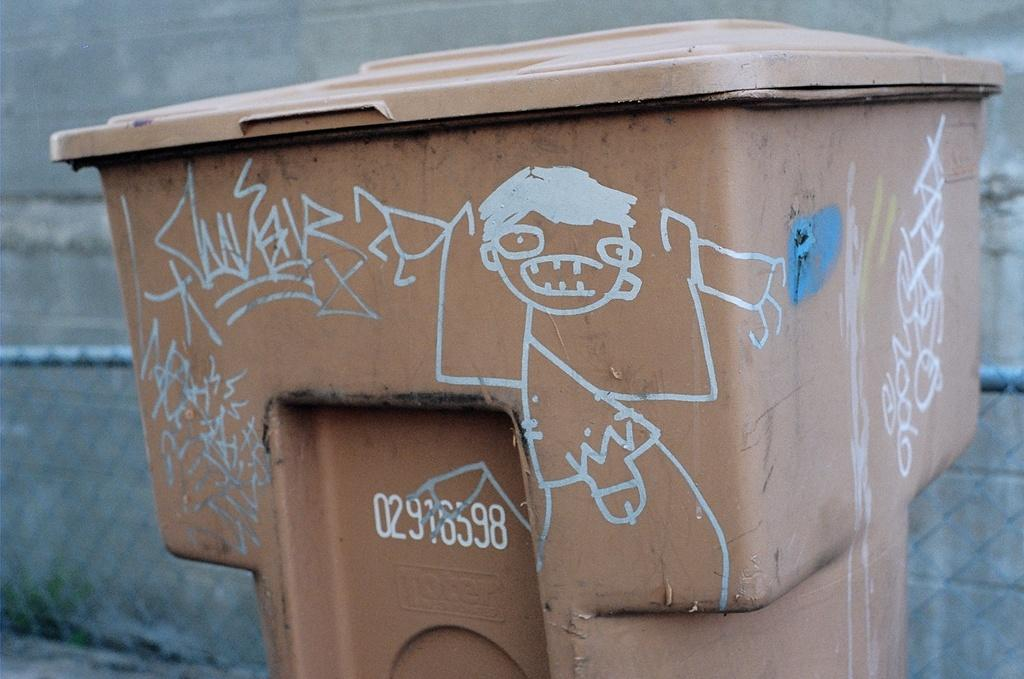<image>
Write a terse but informative summary of the picture. A garbage can with graffiti has the number 012916598 printed on its side. 